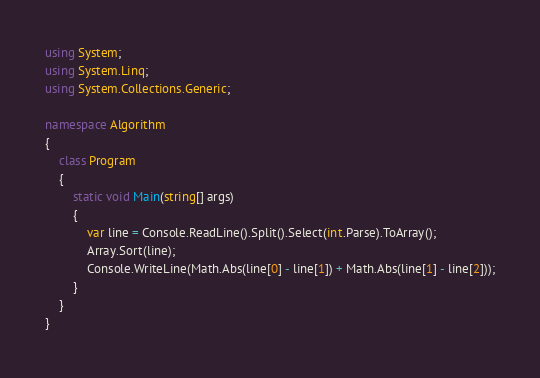Convert code to text. <code><loc_0><loc_0><loc_500><loc_500><_C#_>using System;
using System.Linq;
using System.Collections.Generic;

namespace Algorithm
{
    class Program
    {
        static void Main(string[] args)
        {
            var line = Console.ReadLine().Split().Select(int.Parse).ToArray();
            Array.Sort(line);
            Console.WriteLine(Math.Abs(line[0] - line[1]) + Math.Abs(line[1] - line[2]));
        }
    }
}
</code> 